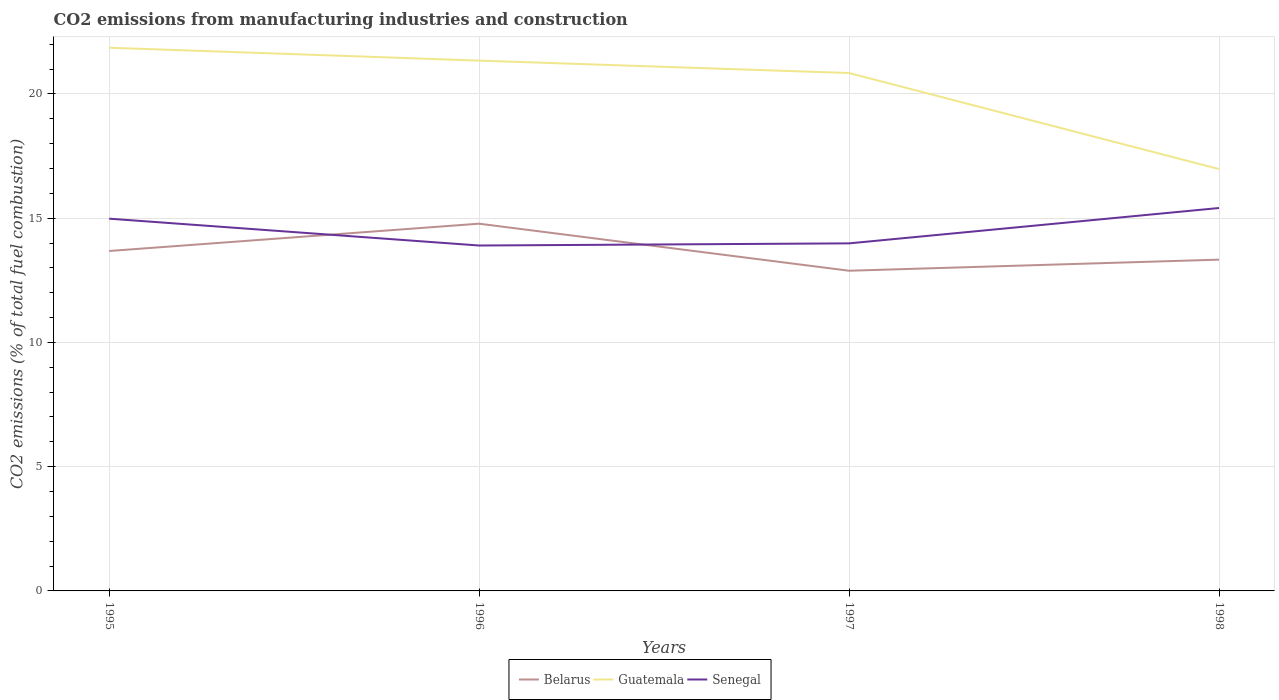Does the line corresponding to Senegal intersect with the line corresponding to Guatemala?
Provide a succinct answer. No. Is the number of lines equal to the number of legend labels?
Give a very brief answer. Yes. Across all years, what is the maximum amount of CO2 emitted in Belarus?
Give a very brief answer. 12.88. What is the total amount of CO2 emitted in Belarus in the graph?
Provide a short and direct response. 0.35. What is the difference between the highest and the second highest amount of CO2 emitted in Senegal?
Your answer should be very brief. 1.51. How many lines are there?
Offer a very short reply. 3. Are the values on the major ticks of Y-axis written in scientific E-notation?
Offer a very short reply. No. Does the graph contain grids?
Your answer should be compact. Yes. Where does the legend appear in the graph?
Offer a terse response. Bottom center. How many legend labels are there?
Keep it short and to the point. 3. What is the title of the graph?
Your answer should be compact. CO2 emissions from manufacturing industries and construction. Does "Turkey" appear as one of the legend labels in the graph?
Your answer should be very brief. No. What is the label or title of the X-axis?
Ensure brevity in your answer.  Years. What is the label or title of the Y-axis?
Make the answer very short. CO2 emissions (% of total fuel combustion). What is the CO2 emissions (% of total fuel combustion) in Belarus in 1995?
Your answer should be compact. 13.68. What is the CO2 emissions (% of total fuel combustion) of Guatemala in 1995?
Your response must be concise. 21.86. What is the CO2 emissions (% of total fuel combustion) in Senegal in 1995?
Provide a succinct answer. 14.98. What is the CO2 emissions (% of total fuel combustion) of Belarus in 1996?
Give a very brief answer. 14.78. What is the CO2 emissions (% of total fuel combustion) in Guatemala in 1996?
Your answer should be very brief. 21.34. What is the CO2 emissions (% of total fuel combustion) in Senegal in 1996?
Ensure brevity in your answer.  13.9. What is the CO2 emissions (% of total fuel combustion) of Belarus in 1997?
Keep it short and to the point. 12.88. What is the CO2 emissions (% of total fuel combustion) of Guatemala in 1997?
Provide a succinct answer. 20.84. What is the CO2 emissions (% of total fuel combustion) in Senegal in 1997?
Your answer should be compact. 13.99. What is the CO2 emissions (% of total fuel combustion) in Belarus in 1998?
Provide a succinct answer. 13.33. What is the CO2 emissions (% of total fuel combustion) of Guatemala in 1998?
Keep it short and to the point. 16.98. What is the CO2 emissions (% of total fuel combustion) of Senegal in 1998?
Make the answer very short. 15.41. Across all years, what is the maximum CO2 emissions (% of total fuel combustion) in Belarus?
Offer a very short reply. 14.78. Across all years, what is the maximum CO2 emissions (% of total fuel combustion) of Guatemala?
Offer a terse response. 21.86. Across all years, what is the maximum CO2 emissions (% of total fuel combustion) in Senegal?
Your response must be concise. 15.41. Across all years, what is the minimum CO2 emissions (% of total fuel combustion) of Belarus?
Provide a succinct answer. 12.88. Across all years, what is the minimum CO2 emissions (% of total fuel combustion) of Guatemala?
Your response must be concise. 16.98. Across all years, what is the minimum CO2 emissions (% of total fuel combustion) in Senegal?
Provide a succinct answer. 13.9. What is the total CO2 emissions (% of total fuel combustion) of Belarus in the graph?
Ensure brevity in your answer.  54.67. What is the total CO2 emissions (% of total fuel combustion) of Guatemala in the graph?
Give a very brief answer. 81.02. What is the total CO2 emissions (% of total fuel combustion) of Senegal in the graph?
Offer a very short reply. 58.27. What is the difference between the CO2 emissions (% of total fuel combustion) in Belarus in 1995 and that in 1996?
Offer a terse response. -1.1. What is the difference between the CO2 emissions (% of total fuel combustion) in Guatemala in 1995 and that in 1996?
Provide a succinct answer. 0.52. What is the difference between the CO2 emissions (% of total fuel combustion) in Senegal in 1995 and that in 1996?
Ensure brevity in your answer.  1.08. What is the difference between the CO2 emissions (% of total fuel combustion) of Belarus in 1995 and that in 1997?
Your answer should be compact. 0.79. What is the difference between the CO2 emissions (% of total fuel combustion) of Guatemala in 1995 and that in 1997?
Your answer should be very brief. 1.02. What is the difference between the CO2 emissions (% of total fuel combustion) in Belarus in 1995 and that in 1998?
Your response must be concise. 0.35. What is the difference between the CO2 emissions (% of total fuel combustion) of Guatemala in 1995 and that in 1998?
Provide a succinct answer. 4.88. What is the difference between the CO2 emissions (% of total fuel combustion) of Senegal in 1995 and that in 1998?
Offer a terse response. -0.43. What is the difference between the CO2 emissions (% of total fuel combustion) in Belarus in 1996 and that in 1997?
Offer a terse response. 1.89. What is the difference between the CO2 emissions (% of total fuel combustion) of Guatemala in 1996 and that in 1997?
Keep it short and to the point. 0.5. What is the difference between the CO2 emissions (% of total fuel combustion) of Senegal in 1996 and that in 1997?
Provide a succinct answer. -0.09. What is the difference between the CO2 emissions (% of total fuel combustion) in Belarus in 1996 and that in 1998?
Make the answer very short. 1.45. What is the difference between the CO2 emissions (% of total fuel combustion) in Guatemala in 1996 and that in 1998?
Give a very brief answer. 4.36. What is the difference between the CO2 emissions (% of total fuel combustion) in Senegal in 1996 and that in 1998?
Offer a terse response. -1.51. What is the difference between the CO2 emissions (% of total fuel combustion) in Belarus in 1997 and that in 1998?
Offer a very short reply. -0.45. What is the difference between the CO2 emissions (% of total fuel combustion) of Guatemala in 1997 and that in 1998?
Give a very brief answer. 3.86. What is the difference between the CO2 emissions (% of total fuel combustion) of Senegal in 1997 and that in 1998?
Give a very brief answer. -1.42. What is the difference between the CO2 emissions (% of total fuel combustion) of Belarus in 1995 and the CO2 emissions (% of total fuel combustion) of Guatemala in 1996?
Keep it short and to the point. -7.66. What is the difference between the CO2 emissions (% of total fuel combustion) in Belarus in 1995 and the CO2 emissions (% of total fuel combustion) in Senegal in 1996?
Make the answer very short. -0.22. What is the difference between the CO2 emissions (% of total fuel combustion) in Guatemala in 1995 and the CO2 emissions (% of total fuel combustion) in Senegal in 1996?
Your answer should be compact. 7.96. What is the difference between the CO2 emissions (% of total fuel combustion) in Belarus in 1995 and the CO2 emissions (% of total fuel combustion) in Guatemala in 1997?
Make the answer very short. -7.16. What is the difference between the CO2 emissions (% of total fuel combustion) in Belarus in 1995 and the CO2 emissions (% of total fuel combustion) in Senegal in 1997?
Keep it short and to the point. -0.31. What is the difference between the CO2 emissions (% of total fuel combustion) in Guatemala in 1995 and the CO2 emissions (% of total fuel combustion) in Senegal in 1997?
Ensure brevity in your answer.  7.87. What is the difference between the CO2 emissions (% of total fuel combustion) of Belarus in 1995 and the CO2 emissions (% of total fuel combustion) of Guatemala in 1998?
Keep it short and to the point. -3.3. What is the difference between the CO2 emissions (% of total fuel combustion) of Belarus in 1995 and the CO2 emissions (% of total fuel combustion) of Senegal in 1998?
Ensure brevity in your answer.  -1.73. What is the difference between the CO2 emissions (% of total fuel combustion) of Guatemala in 1995 and the CO2 emissions (% of total fuel combustion) of Senegal in 1998?
Make the answer very short. 6.45. What is the difference between the CO2 emissions (% of total fuel combustion) of Belarus in 1996 and the CO2 emissions (% of total fuel combustion) of Guatemala in 1997?
Offer a terse response. -6.06. What is the difference between the CO2 emissions (% of total fuel combustion) of Belarus in 1996 and the CO2 emissions (% of total fuel combustion) of Senegal in 1997?
Ensure brevity in your answer.  0.79. What is the difference between the CO2 emissions (% of total fuel combustion) of Guatemala in 1996 and the CO2 emissions (% of total fuel combustion) of Senegal in 1997?
Keep it short and to the point. 7.35. What is the difference between the CO2 emissions (% of total fuel combustion) in Belarus in 1996 and the CO2 emissions (% of total fuel combustion) in Guatemala in 1998?
Provide a succinct answer. -2.2. What is the difference between the CO2 emissions (% of total fuel combustion) of Belarus in 1996 and the CO2 emissions (% of total fuel combustion) of Senegal in 1998?
Keep it short and to the point. -0.63. What is the difference between the CO2 emissions (% of total fuel combustion) of Guatemala in 1996 and the CO2 emissions (% of total fuel combustion) of Senegal in 1998?
Your answer should be very brief. 5.93. What is the difference between the CO2 emissions (% of total fuel combustion) of Belarus in 1997 and the CO2 emissions (% of total fuel combustion) of Guatemala in 1998?
Offer a very short reply. -4.09. What is the difference between the CO2 emissions (% of total fuel combustion) in Belarus in 1997 and the CO2 emissions (% of total fuel combustion) in Senegal in 1998?
Keep it short and to the point. -2.52. What is the difference between the CO2 emissions (% of total fuel combustion) of Guatemala in 1997 and the CO2 emissions (% of total fuel combustion) of Senegal in 1998?
Your answer should be compact. 5.43. What is the average CO2 emissions (% of total fuel combustion) of Belarus per year?
Your answer should be very brief. 13.67. What is the average CO2 emissions (% of total fuel combustion) in Guatemala per year?
Ensure brevity in your answer.  20.25. What is the average CO2 emissions (% of total fuel combustion) in Senegal per year?
Offer a terse response. 14.57. In the year 1995, what is the difference between the CO2 emissions (% of total fuel combustion) of Belarus and CO2 emissions (% of total fuel combustion) of Guatemala?
Your answer should be compact. -8.18. In the year 1995, what is the difference between the CO2 emissions (% of total fuel combustion) of Belarus and CO2 emissions (% of total fuel combustion) of Senegal?
Provide a short and direct response. -1.3. In the year 1995, what is the difference between the CO2 emissions (% of total fuel combustion) in Guatemala and CO2 emissions (% of total fuel combustion) in Senegal?
Make the answer very short. 6.88. In the year 1996, what is the difference between the CO2 emissions (% of total fuel combustion) in Belarus and CO2 emissions (% of total fuel combustion) in Guatemala?
Ensure brevity in your answer.  -6.56. In the year 1996, what is the difference between the CO2 emissions (% of total fuel combustion) of Belarus and CO2 emissions (% of total fuel combustion) of Senegal?
Make the answer very short. 0.88. In the year 1996, what is the difference between the CO2 emissions (% of total fuel combustion) of Guatemala and CO2 emissions (% of total fuel combustion) of Senegal?
Keep it short and to the point. 7.44. In the year 1997, what is the difference between the CO2 emissions (% of total fuel combustion) of Belarus and CO2 emissions (% of total fuel combustion) of Guatemala?
Your response must be concise. -7.96. In the year 1997, what is the difference between the CO2 emissions (% of total fuel combustion) in Belarus and CO2 emissions (% of total fuel combustion) in Senegal?
Ensure brevity in your answer.  -1.1. In the year 1997, what is the difference between the CO2 emissions (% of total fuel combustion) of Guatemala and CO2 emissions (% of total fuel combustion) of Senegal?
Provide a succinct answer. 6.85. In the year 1998, what is the difference between the CO2 emissions (% of total fuel combustion) of Belarus and CO2 emissions (% of total fuel combustion) of Guatemala?
Ensure brevity in your answer.  -3.65. In the year 1998, what is the difference between the CO2 emissions (% of total fuel combustion) of Belarus and CO2 emissions (% of total fuel combustion) of Senegal?
Your answer should be compact. -2.08. In the year 1998, what is the difference between the CO2 emissions (% of total fuel combustion) of Guatemala and CO2 emissions (% of total fuel combustion) of Senegal?
Your answer should be very brief. 1.57. What is the ratio of the CO2 emissions (% of total fuel combustion) in Belarus in 1995 to that in 1996?
Your answer should be very brief. 0.93. What is the ratio of the CO2 emissions (% of total fuel combustion) in Guatemala in 1995 to that in 1996?
Your answer should be very brief. 1.02. What is the ratio of the CO2 emissions (% of total fuel combustion) of Senegal in 1995 to that in 1996?
Provide a succinct answer. 1.08. What is the ratio of the CO2 emissions (% of total fuel combustion) of Belarus in 1995 to that in 1997?
Keep it short and to the point. 1.06. What is the ratio of the CO2 emissions (% of total fuel combustion) of Guatemala in 1995 to that in 1997?
Give a very brief answer. 1.05. What is the ratio of the CO2 emissions (% of total fuel combustion) in Senegal in 1995 to that in 1997?
Provide a short and direct response. 1.07. What is the ratio of the CO2 emissions (% of total fuel combustion) in Belarus in 1995 to that in 1998?
Ensure brevity in your answer.  1.03. What is the ratio of the CO2 emissions (% of total fuel combustion) in Guatemala in 1995 to that in 1998?
Make the answer very short. 1.29. What is the ratio of the CO2 emissions (% of total fuel combustion) in Senegal in 1995 to that in 1998?
Your answer should be very brief. 0.97. What is the ratio of the CO2 emissions (% of total fuel combustion) of Belarus in 1996 to that in 1997?
Keep it short and to the point. 1.15. What is the ratio of the CO2 emissions (% of total fuel combustion) in Guatemala in 1996 to that in 1997?
Give a very brief answer. 1.02. What is the ratio of the CO2 emissions (% of total fuel combustion) of Belarus in 1996 to that in 1998?
Make the answer very short. 1.11. What is the ratio of the CO2 emissions (% of total fuel combustion) of Guatemala in 1996 to that in 1998?
Your answer should be compact. 1.26. What is the ratio of the CO2 emissions (% of total fuel combustion) in Senegal in 1996 to that in 1998?
Your answer should be very brief. 0.9. What is the ratio of the CO2 emissions (% of total fuel combustion) of Belarus in 1997 to that in 1998?
Provide a succinct answer. 0.97. What is the ratio of the CO2 emissions (% of total fuel combustion) in Guatemala in 1997 to that in 1998?
Make the answer very short. 1.23. What is the ratio of the CO2 emissions (% of total fuel combustion) of Senegal in 1997 to that in 1998?
Ensure brevity in your answer.  0.91. What is the difference between the highest and the second highest CO2 emissions (% of total fuel combustion) of Belarus?
Offer a terse response. 1.1. What is the difference between the highest and the second highest CO2 emissions (% of total fuel combustion) in Guatemala?
Your response must be concise. 0.52. What is the difference between the highest and the second highest CO2 emissions (% of total fuel combustion) of Senegal?
Keep it short and to the point. 0.43. What is the difference between the highest and the lowest CO2 emissions (% of total fuel combustion) in Belarus?
Offer a very short reply. 1.89. What is the difference between the highest and the lowest CO2 emissions (% of total fuel combustion) in Guatemala?
Offer a very short reply. 4.88. What is the difference between the highest and the lowest CO2 emissions (% of total fuel combustion) in Senegal?
Your answer should be compact. 1.51. 